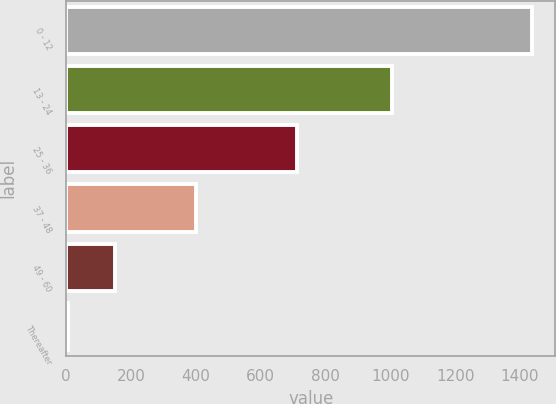<chart> <loc_0><loc_0><loc_500><loc_500><bar_chart><fcel>0 - 12<fcel>13 - 24<fcel>25 - 36<fcel>37 - 48<fcel>49 - 60<fcel>Thereafter<nl><fcel>1437<fcel>1004<fcel>712<fcel>399<fcel>150<fcel>7<nl></chart> 